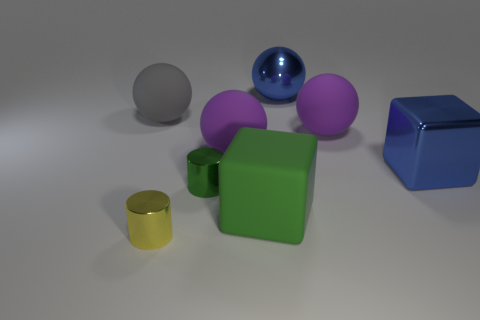Subtract all blue metallic spheres. How many spheres are left? 3 Subtract all cyan cylinders. How many purple spheres are left? 2 Subtract all cubes. How many objects are left? 6 Add 2 tiny yellow cylinders. How many objects exist? 10 Subtract all blue balls. How many balls are left? 3 Subtract 2 balls. How many balls are left? 2 Add 6 brown rubber cubes. How many brown rubber cubes exist? 6 Subtract 0 purple blocks. How many objects are left? 8 Subtract all red spheres. Subtract all purple cubes. How many spheres are left? 4 Subtract all small blue rubber spheres. Subtract all large metallic objects. How many objects are left? 6 